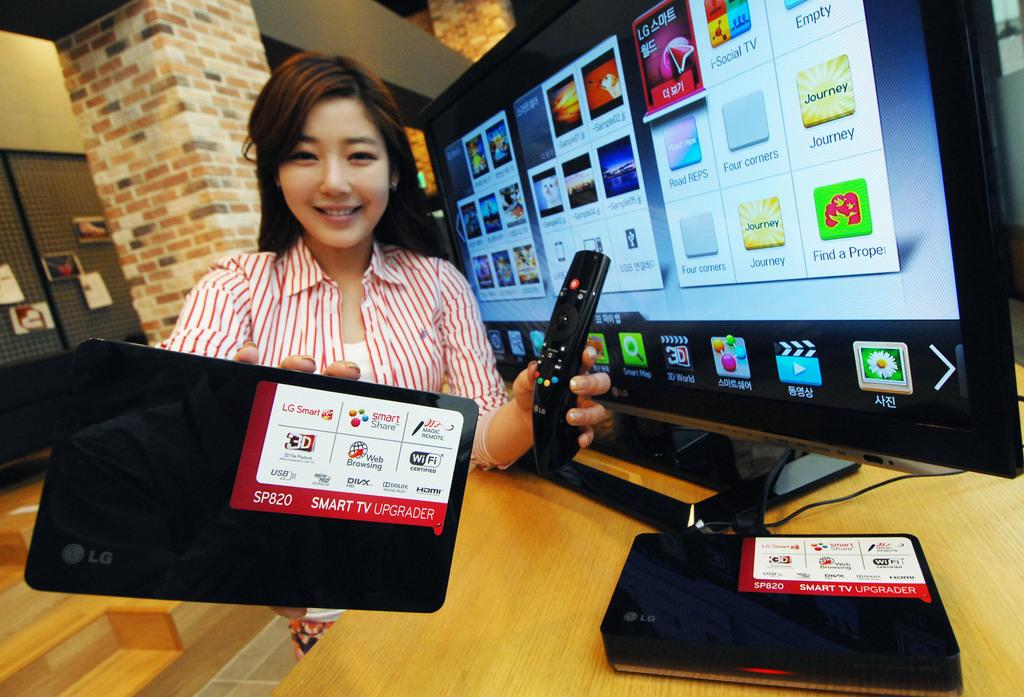<image>
Give a short and clear explanation of the subsequent image. An attractive young woman is handing over an LG brand smart TV upgrader. 